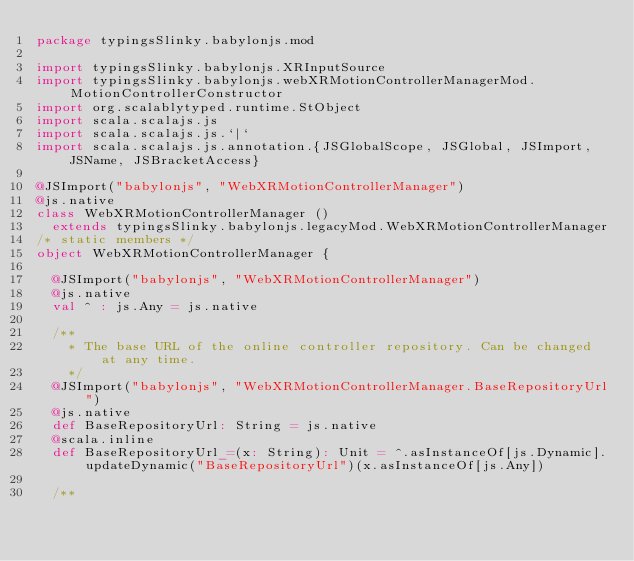<code> <loc_0><loc_0><loc_500><loc_500><_Scala_>package typingsSlinky.babylonjs.mod

import typingsSlinky.babylonjs.XRInputSource
import typingsSlinky.babylonjs.webXRMotionControllerManagerMod.MotionControllerConstructor
import org.scalablytyped.runtime.StObject
import scala.scalajs.js
import scala.scalajs.js.`|`
import scala.scalajs.js.annotation.{JSGlobalScope, JSGlobal, JSImport, JSName, JSBracketAccess}

@JSImport("babylonjs", "WebXRMotionControllerManager")
@js.native
class WebXRMotionControllerManager ()
  extends typingsSlinky.babylonjs.legacyMod.WebXRMotionControllerManager
/* static members */
object WebXRMotionControllerManager {
  
  @JSImport("babylonjs", "WebXRMotionControllerManager")
  @js.native
  val ^ : js.Any = js.native
  
  /**
    * The base URL of the online controller repository. Can be changed at any time.
    */
  @JSImport("babylonjs", "WebXRMotionControllerManager.BaseRepositoryUrl")
  @js.native
  def BaseRepositoryUrl: String = js.native
  @scala.inline
  def BaseRepositoryUrl_=(x: String): Unit = ^.asInstanceOf[js.Dynamic].updateDynamic("BaseRepositoryUrl")(x.asInstanceOf[js.Any])
  
  /**</code> 